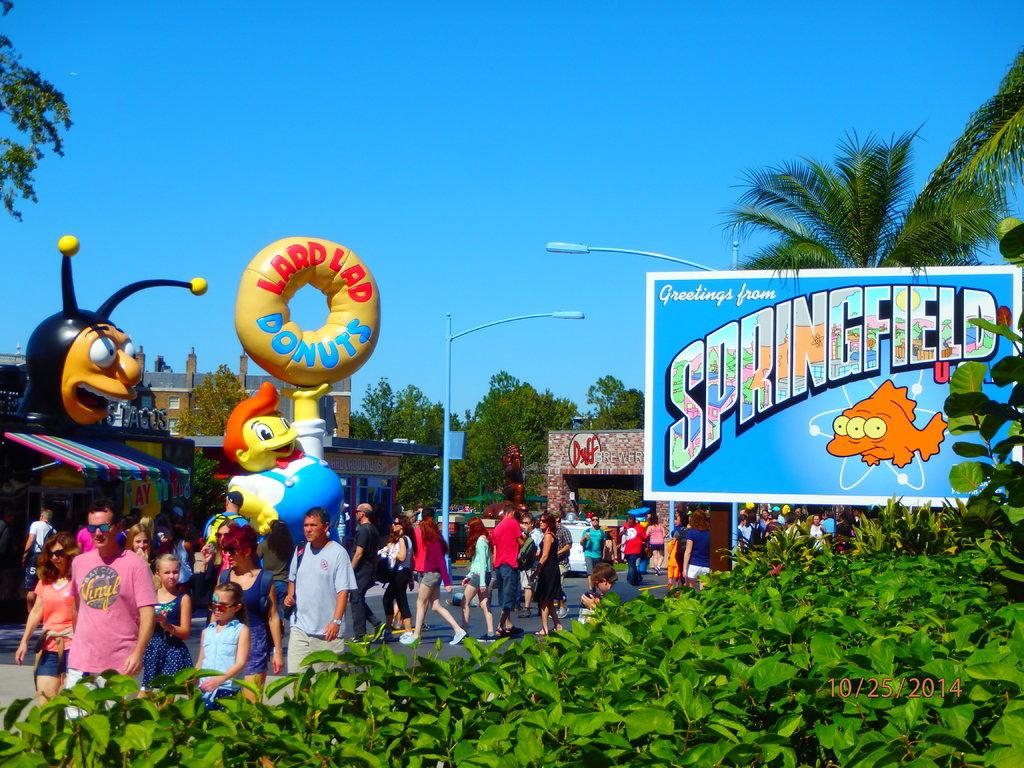What are the people in the image doing? The people in the image are walking on the road. What else can be seen in the image besides the people? There are toys, buildings, and trees visible in the background of the image. What is the board in the image used for? The purpose of the board in the image is not specified, but it could be a sign or notice board. What type of church can be seen in the image? There is no church present in the image. What time of day is it in the image, considering the presence of a carriage? There is no carriage present in the image, and therefore we cannot determine the time of day based on this object. 